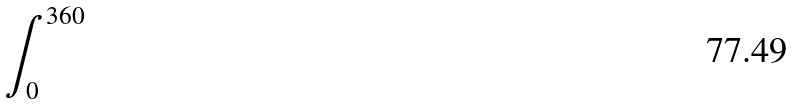<formula> <loc_0><loc_0><loc_500><loc_500>\int _ { 0 } ^ { 3 6 0 }</formula> 